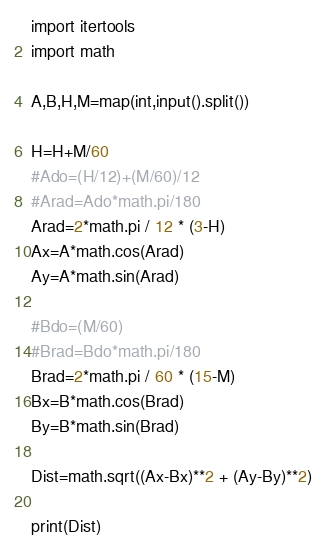<code> <loc_0><loc_0><loc_500><loc_500><_Python_>import itertools
import math

A,B,H,M=map(int,input().split())

H=H+M/60
#Ado=(H/12)+(M/60)/12
#Arad=Ado*math.pi/180
Arad=2*math.pi / 12 * (3-H)
Ax=A*math.cos(Arad)
Ay=A*math.sin(Arad)

#Bdo=(M/60)
#Brad=Bdo*math.pi/180
Brad=2*math.pi / 60 * (15-M)
Bx=B*math.cos(Brad)
By=B*math.sin(Brad)

Dist=math.sqrt((Ax-Bx)**2 + (Ay-By)**2)

print(Dist)
</code> 